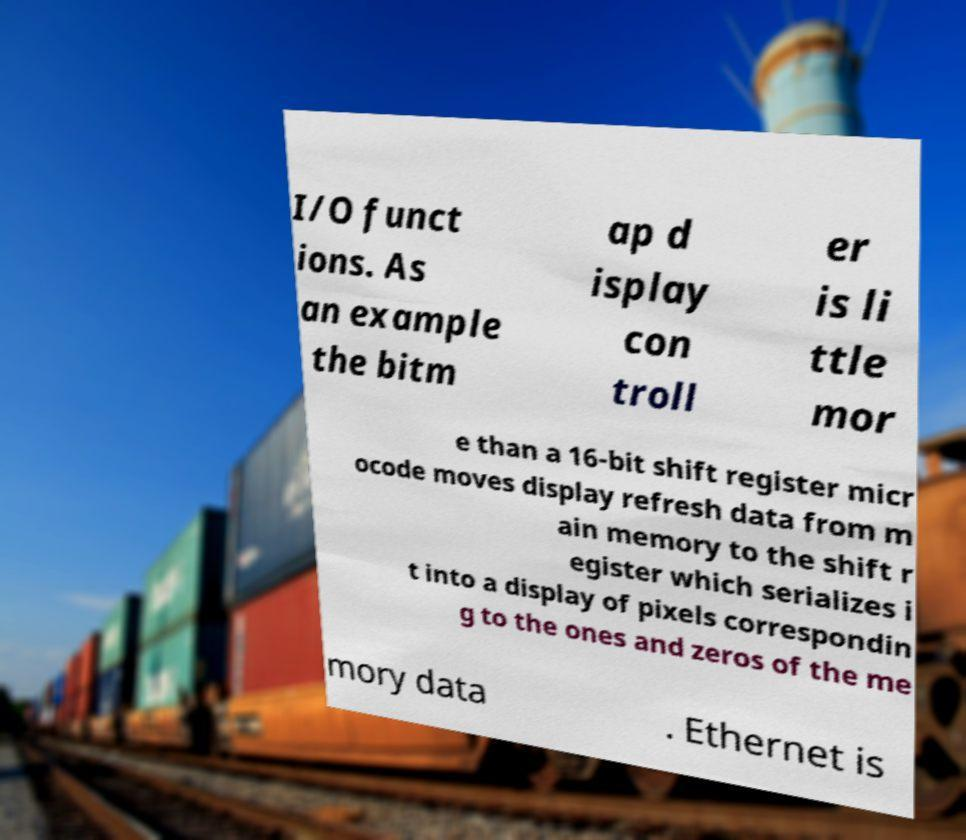For documentation purposes, I need the text within this image transcribed. Could you provide that? I/O funct ions. As an example the bitm ap d isplay con troll er is li ttle mor e than a 16-bit shift register micr ocode moves display refresh data from m ain memory to the shift r egister which serializes i t into a display of pixels correspondin g to the ones and zeros of the me mory data . Ethernet is 